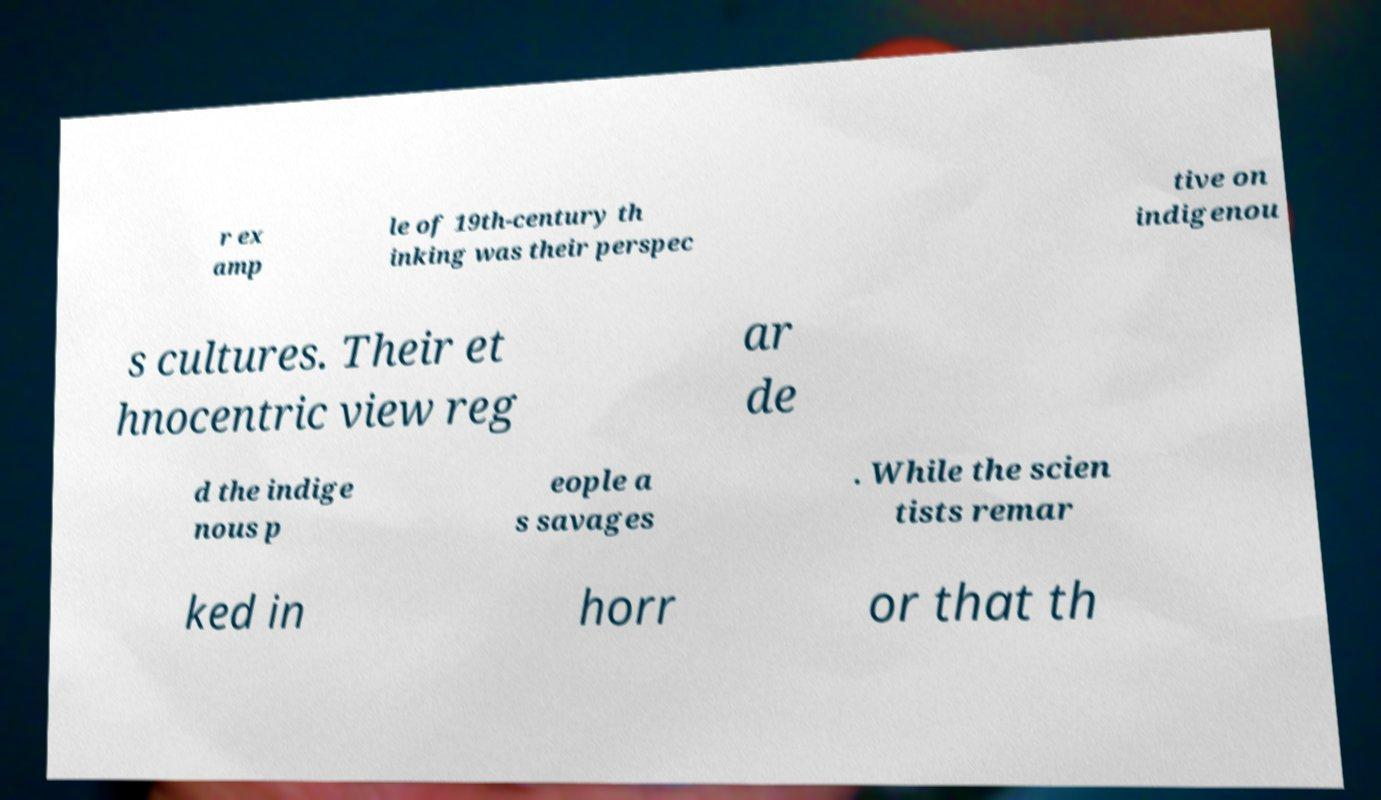Can you accurately transcribe the text from the provided image for me? r ex amp le of 19th-century th inking was their perspec tive on indigenou s cultures. Their et hnocentric view reg ar de d the indige nous p eople a s savages . While the scien tists remar ked in horr or that th 